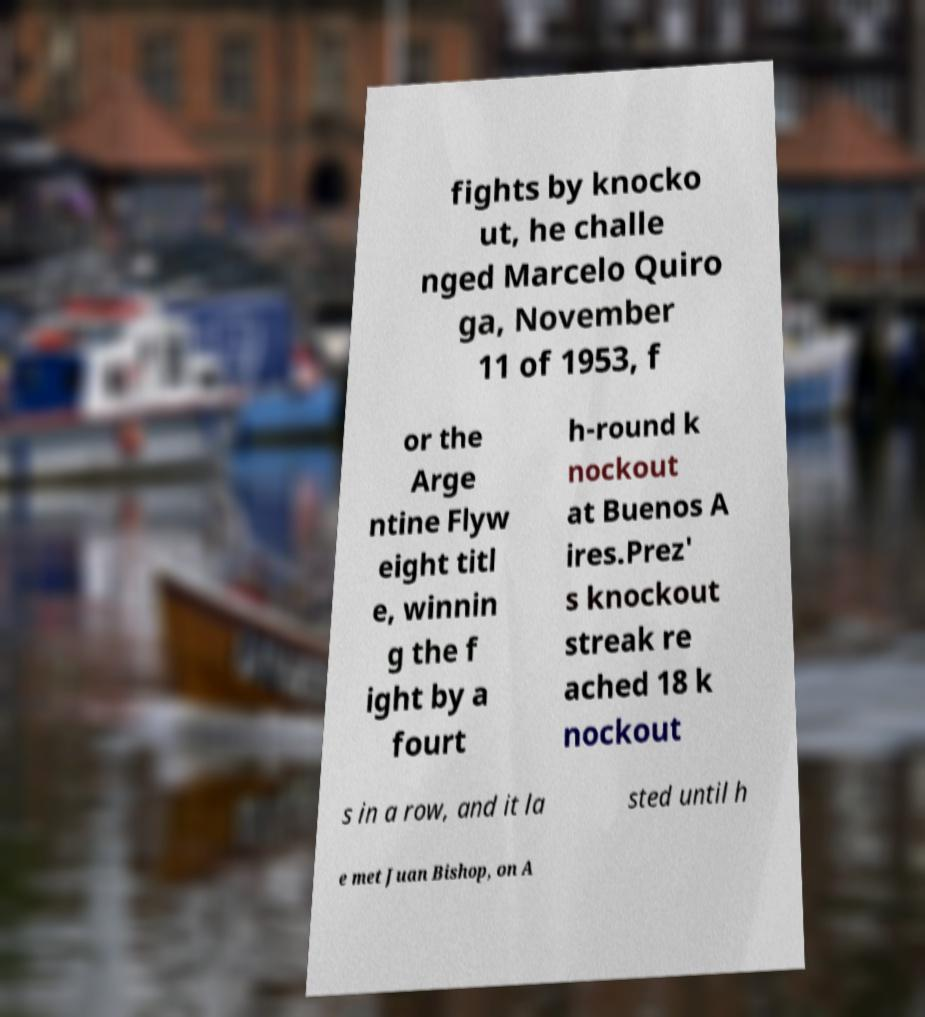Could you assist in decoding the text presented in this image and type it out clearly? fights by knocko ut, he challe nged Marcelo Quiro ga, November 11 of 1953, f or the Arge ntine Flyw eight titl e, winnin g the f ight by a fourt h-round k nockout at Buenos A ires.Prez' s knockout streak re ached 18 k nockout s in a row, and it la sted until h e met Juan Bishop, on A 